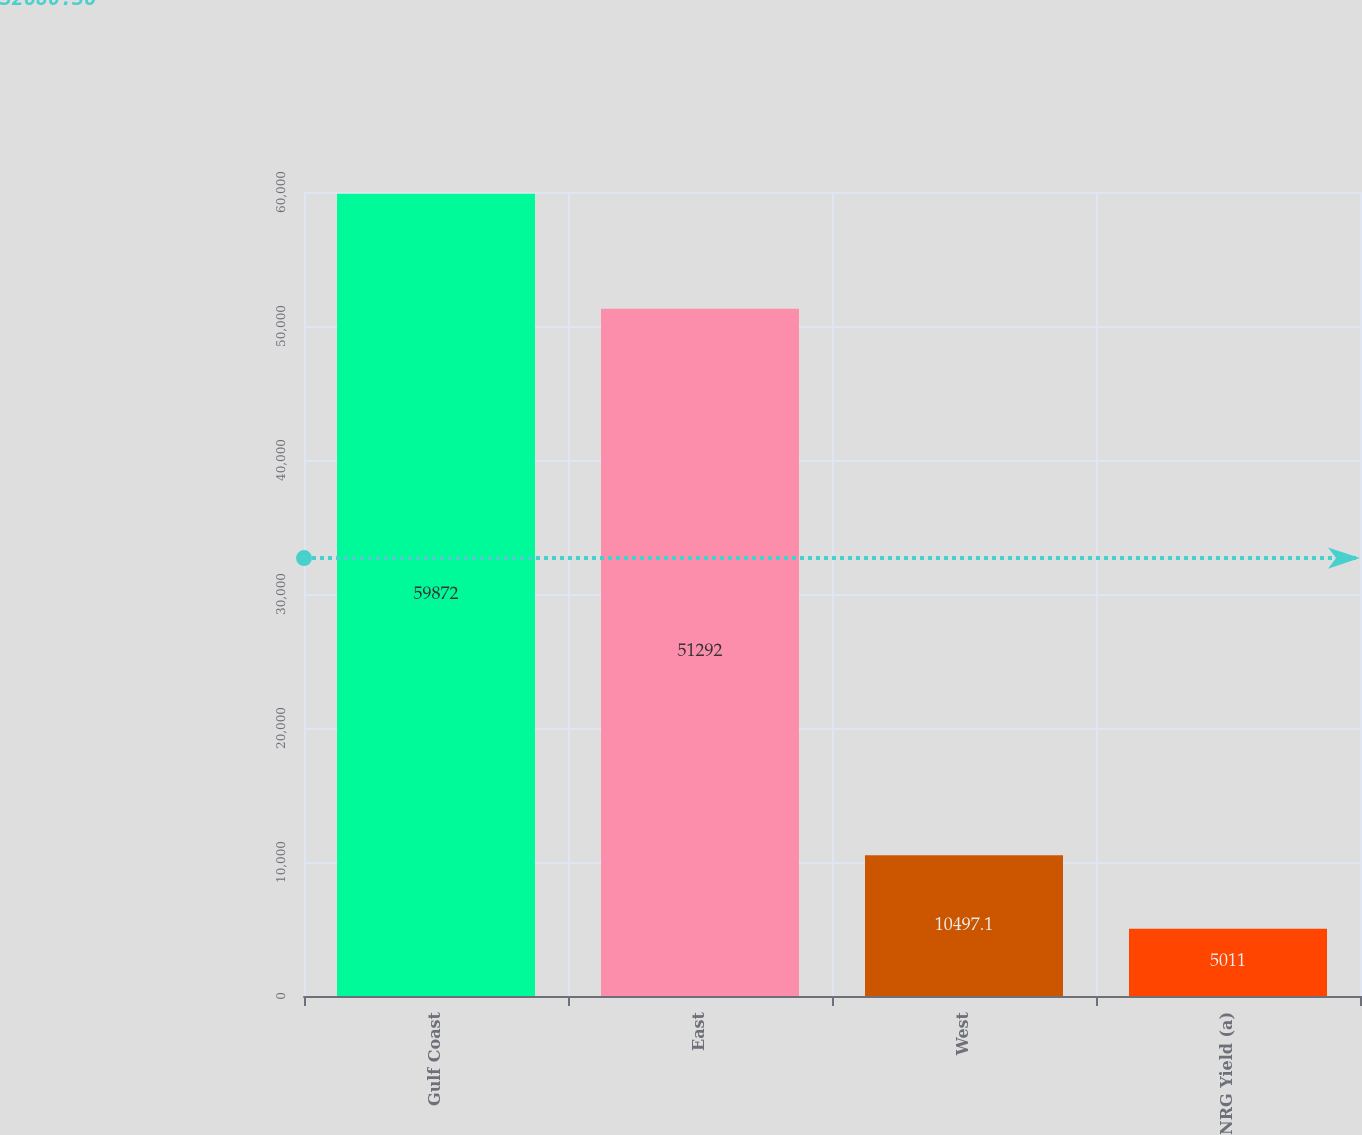<chart> <loc_0><loc_0><loc_500><loc_500><bar_chart><fcel>Gulf Coast<fcel>East<fcel>West<fcel>NRG Yield (a)<nl><fcel>59872<fcel>51292<fcel>10497.1<fcel>5011<nl></chart> 